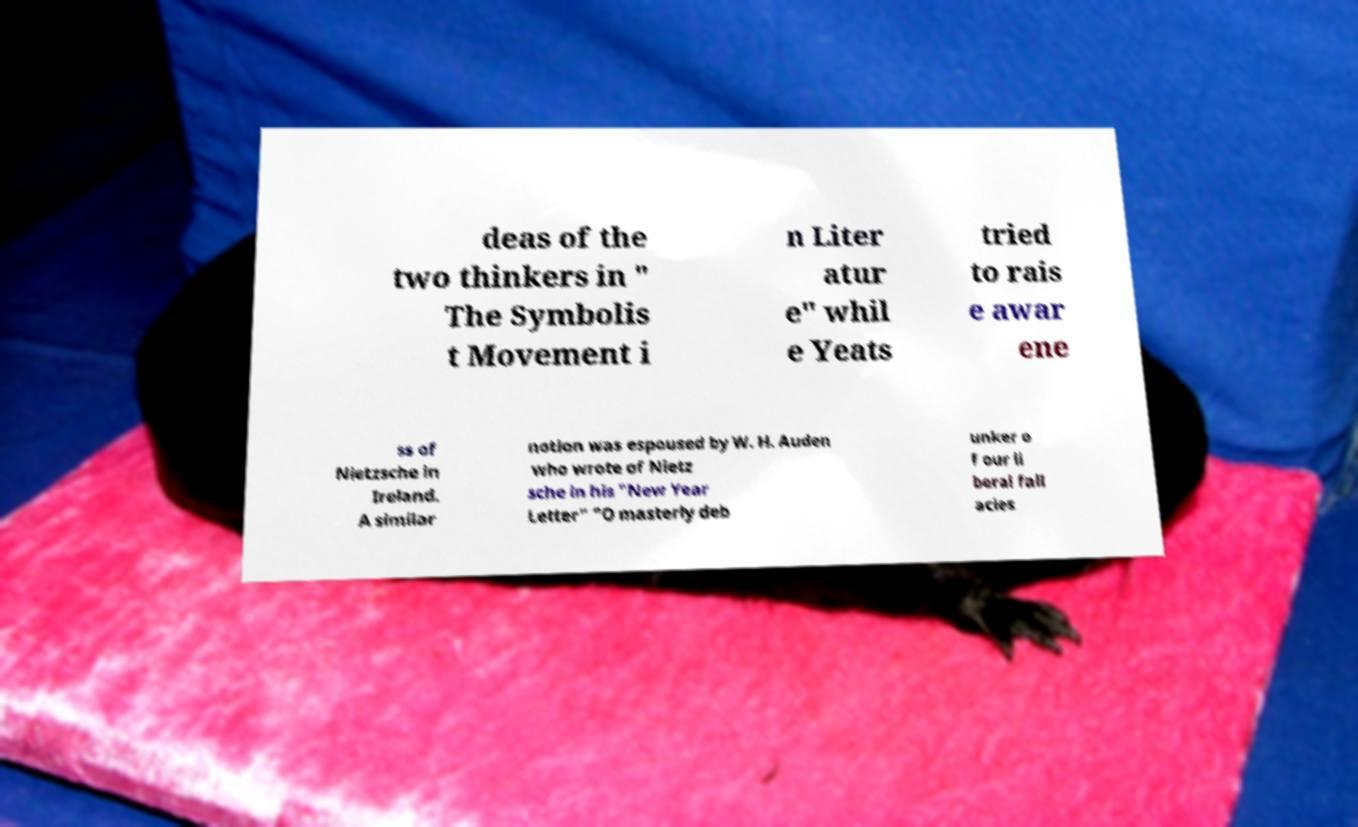What messages or text are displayed in this image? I need them in a readable, typed format. deas of the two thinkers in " The Symbolis t Movement i n Liter atur e" whil e Yeats tried to rais e awar ene ss of Nietzsche in Ireland. A similar notion was espoused by W. H. Auden who wrote of Nietz sche in his "New Year Letter" "O masterly deb unker o f our li beral fall acies 